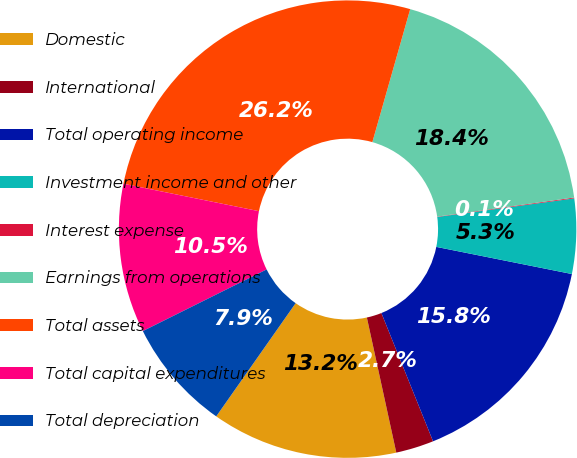<chart> <loc_0><loc_0><loc_500><loc_500><pie_chart><fcel>Domestic<fcel>International<fcel>Total operating income<fcel>Investment income and other<fcel>Interest expense<fcel>Earnings from operations<fcel>Total assets<fcel>Total capital expenditures<fcel>Total depreciation<nl><fcel>13.15%<fcel>2.68%<fcel>15.76%<fcel>5.29%<fcel>0.06%<fcel>18.38%<fcel>26.23%<fcel>10.53%<fcel>7.91%<nl></chart> 